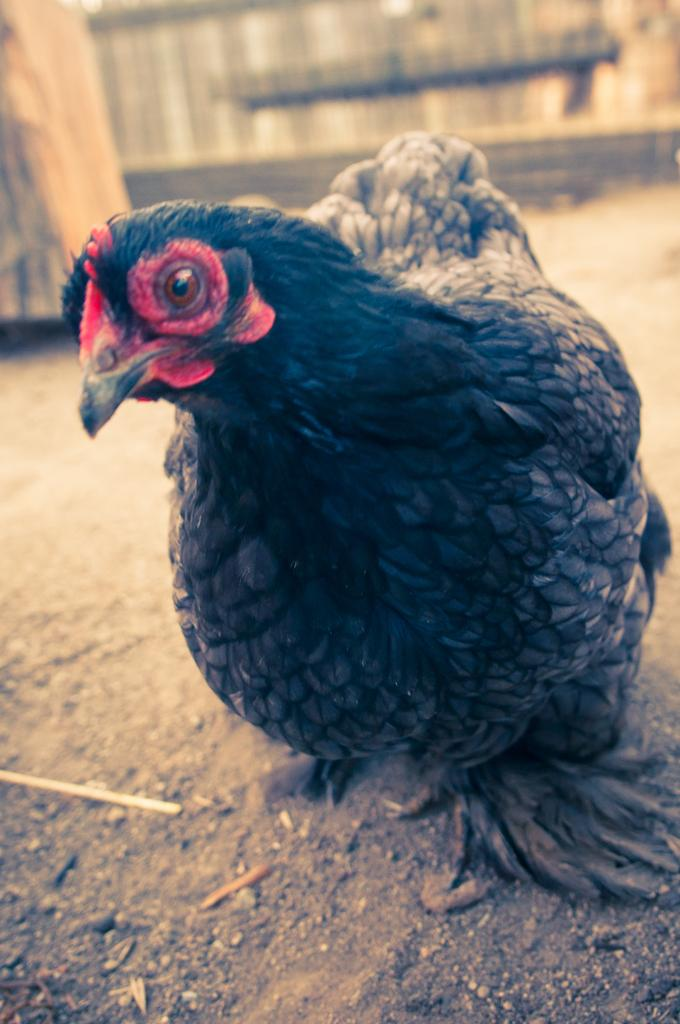What type of animal can be seen in the image? There is a bird in the image. What color is the bird? The bird is black in color. How does the bird resemble a hen? The bird resembles a hen in appearance. Where is the bird located in the image? The bird is on the land. What can be observed about the background of the image? The background of the image is blurred. What body part of the bird is used to cry? The bird does not have a body part specifically used for crying, as birds do not cry like humans. 